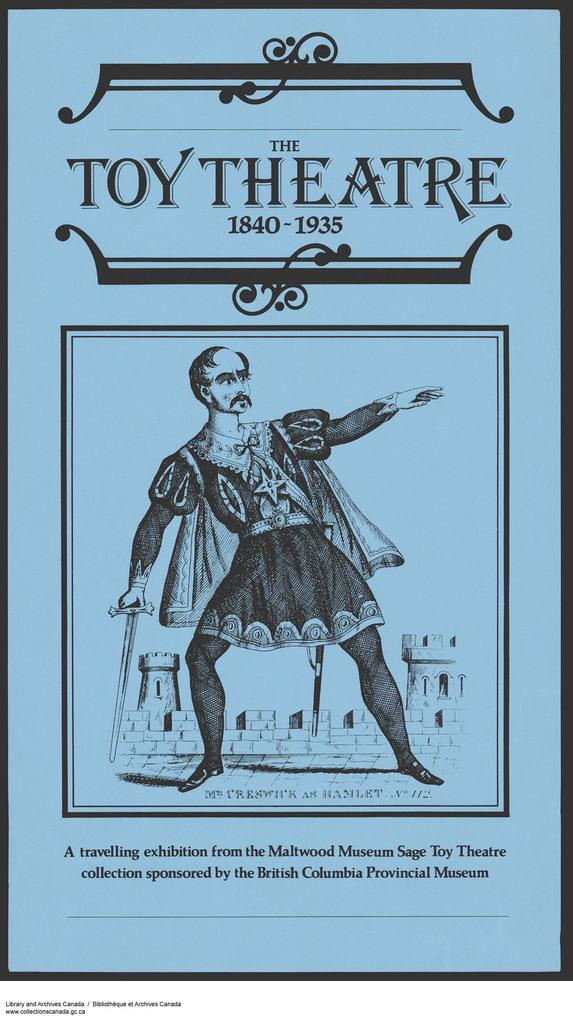What is the main subject of the image? The main subject of the image is a cover page. What is depicted on the cover page? The cover page features a man. Reasoning: Let's think step by step by step in order to produce the conversation. We start by identifying the main subject of the image, which is the cover page. Then, we describe the content of the cover page, which features a man. Each question is designed to elicit a specific detail about the image that is known from the provided facts. Absurd Question/Answer: What type of jewel is the man holding in the image? There is no jewel present in the image; the cover page features a man without any additional objects. What type of market is the man visiting in the image? There is no market present in the image; the cover page features a man without any additional context or location. --- Facts: 1. There is a person sitting on a chair in the image. 2. The person is holding a book. 3. The book has a blue cover. 4. There is a table next to the chair. 5. The table has a lamp on it. Absurd Topics: elephant, ocean, dance Conversation: What is the person in the image doing? The person in the image is sitting on a chair. What is the person holding in the image? The person is holding a book. What color is the book's cover? The book has a blue cover. What is on the table next to the chair? There is a lamp on the table. Reasoning: Let's think step by step in order to produce the conversation. We start by identifying the main subject of the image, which is the person sitting on a chair. Then, we describe what the person is holding, which is a book with a blue cover. Next, we mention the presence of a table next to the chair and describe what is on the table, which is a lamp. Each question is designed to elicit a specific detail about the image that is known from the provided facts 